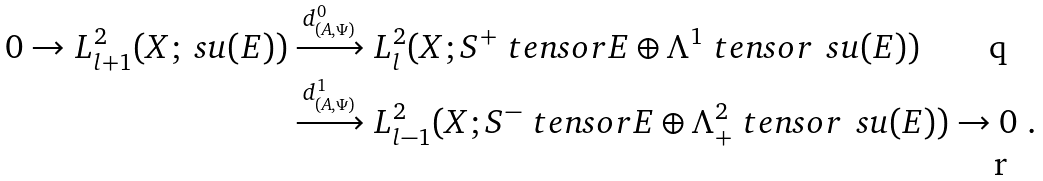<formula> <loc_0><loc_0><loc_500><loc_500>0 \to L ^ { 2 } _ { l + 1 } ( X ; \ s u ( E ) ) & \xrightarrow { d ^ { 0 } _ { ( A , \Psi ) } } L ^ { 2 } _ { l } ( X ; S ^ { + } \ t e n s o r E \oplus \Lambda ^ { 1 } \ t e n s o r \, \ s u ( E ) ) \\ & \xrightarrow { d ^ { 1 } _ { ( A , \Psi ) } } L ^ { 2 } _ { l - 1 } ( X ; S ^ { - } \ t e n s o r E \oplus \Lambda ^ { 2 } _ { + } \ t e n s o r \, \ s u ( E ) ) \to 0 \ .</formula> 